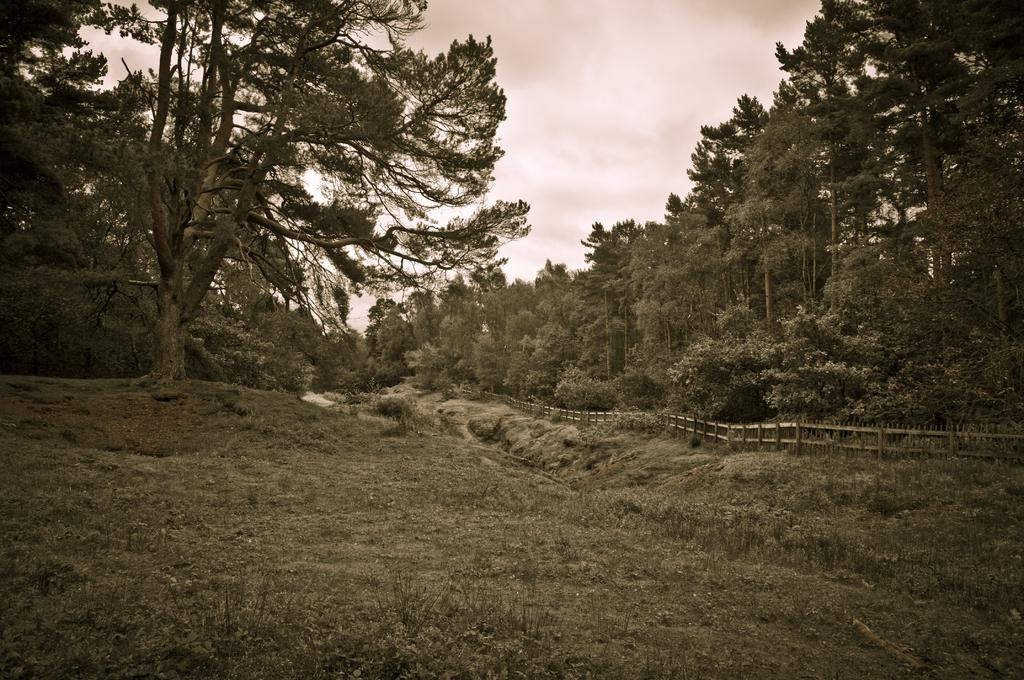What type of vegetation can be seen in the image? There are trees, plants, and grass in the image. What kind of barrier is present in the image? There is a fence in the image. What part of the natural environment is visible in the image? The sky is visible in the image. What color is the chalk used to draw on the fence in the image? There is no chalk or drawing on the fence in the image. What is the interest rate for the van in the image? There is no van or mention of interest rates in the image. 